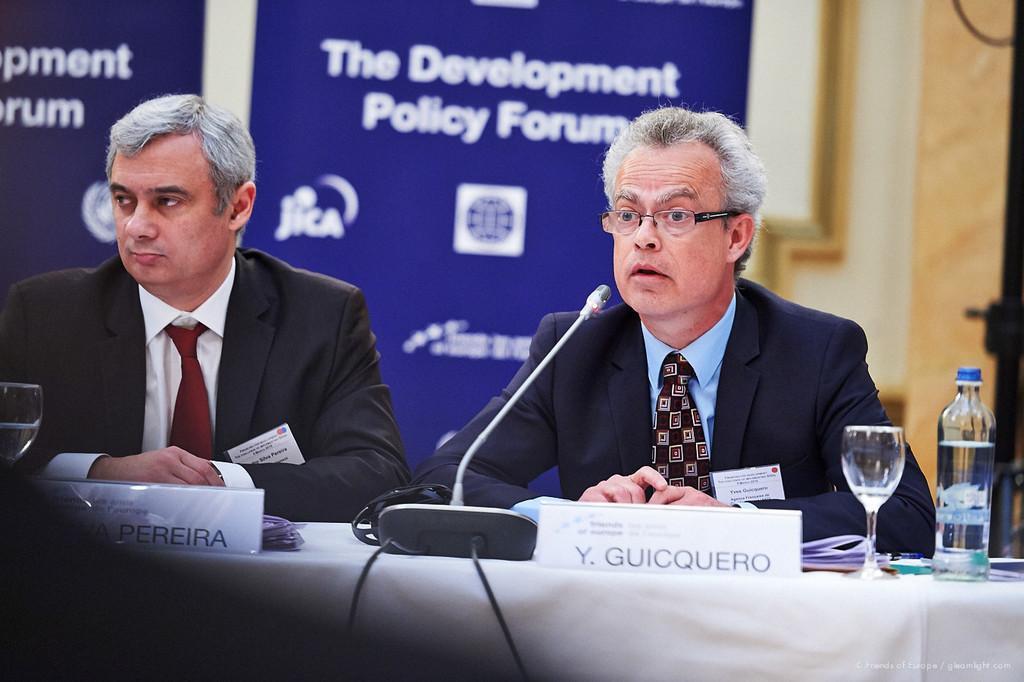Can you describe this image briefly? In the center of the image there are two persons wearing suit and sitting on chairs. In front of them there is a table with white color cloth. There is a glass. There is a water bottle. There is a mic. In the background of the image there is a banner with some text. 